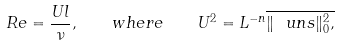Convert formula to latex. <formula><loc_0><loc_0><loc_500><loc_500>R e = \frac { U l } { \nu } , \quad w h e r e \quad U ^ { 2 } = L ^ { - n } \overline { \| \ u n s \| _ { 0 } ^ { 2 } , }</formula> 